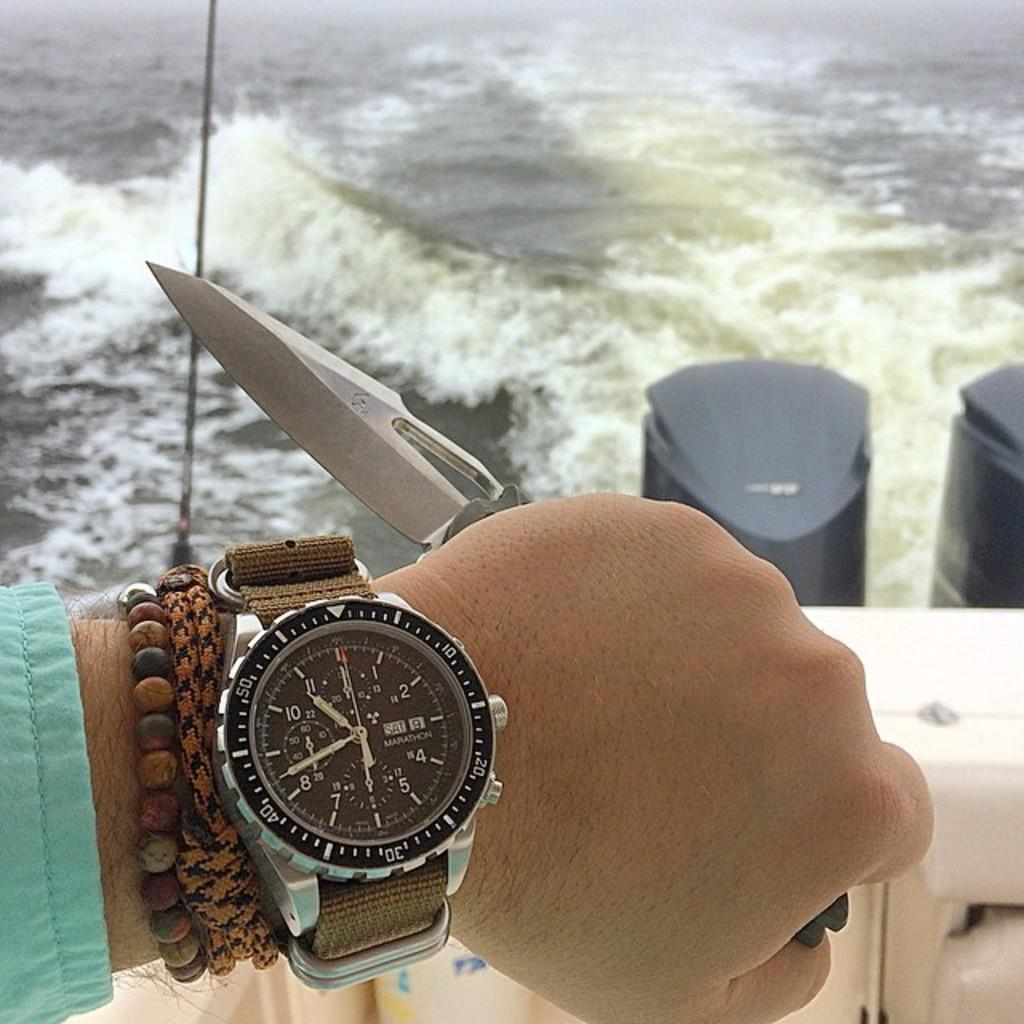<image>
Summarize the visual content of the image. A man displays his Marathon wrist watch on Saturday the 9th, while holding a knife on a boat. 